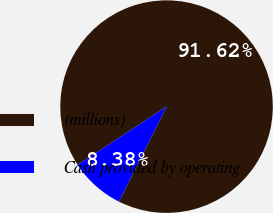<chart> <loc_0><loc_0><loc_500><loc_500><pie_chart><fcel>(millions)<fcel>Cash provided by operating<nl><fcel>91.62%<fcel>8.38%<nl></chart> 